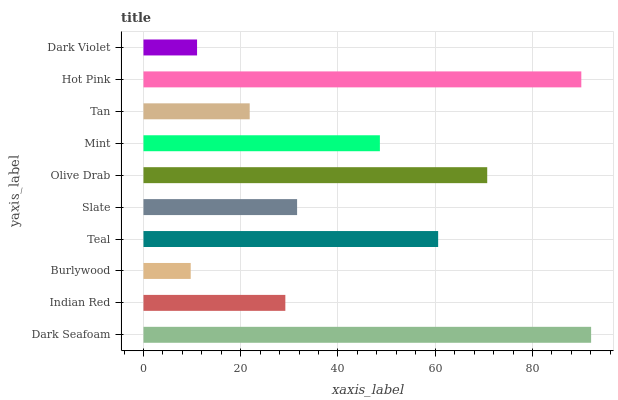Is Burlywood the minimum?
Answer yes or no. Yes. Is Dark Seafoam the maximum?
Answer yes or no. Yes. Is Indian Red the minimum?
Answer yes or no. No. Is Indian Red the maximum?
Answer yes or no. No. Is Dark Seafoam greater than Indian Red?
Answer yes or no. Yes. Is Indian Red less than Dark Seafoam?
Answer yes or no. Yes. Is Indian Red greater than Dark Seafoam?
Answer yes or no. No. Is Dark Seafoam less than Indian Red?
Answer yes or no. No. Is Mint the high median?
Answer yes or no. Yes. Is Slate the low median?
Answer yes or no. Yes. Is Hot Pink the high median?
Answer yes or no. No. Is Burlywood the low median?
Answer yes or no. No. 